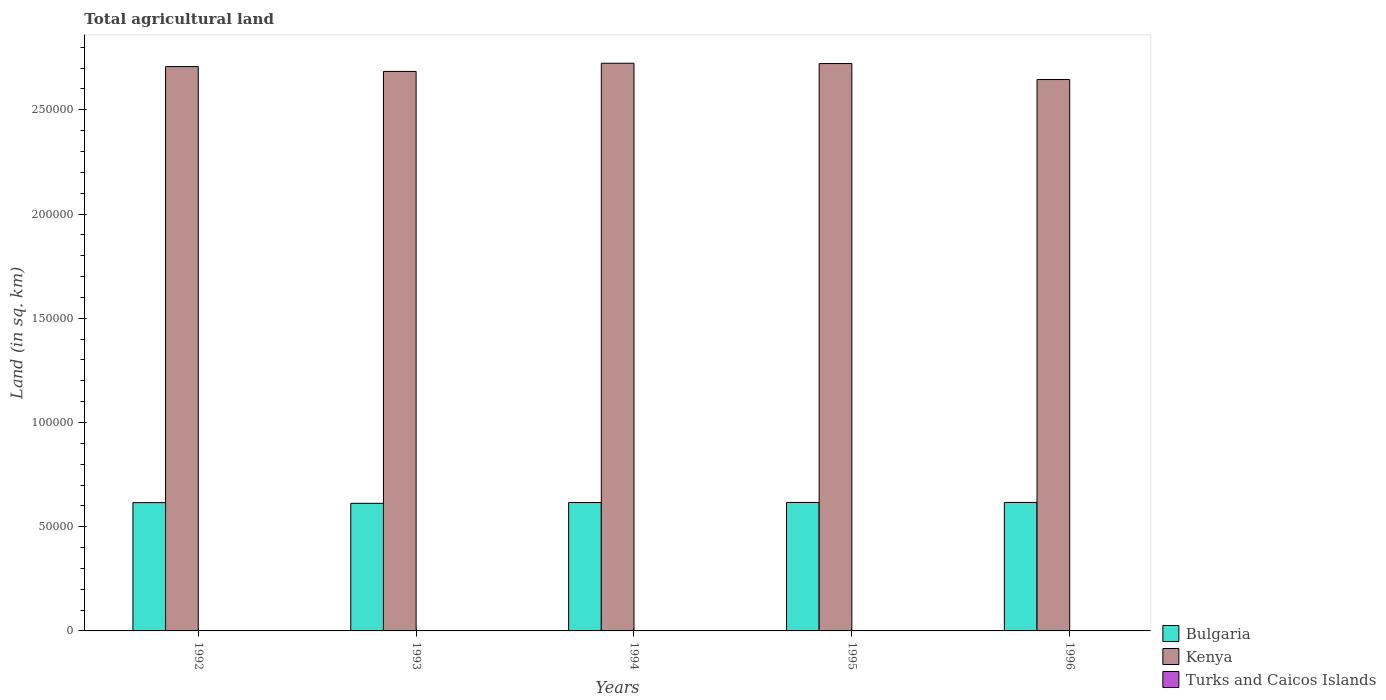How many groups of bars are there?
Provide a short and direct response. 5. Are the number of bars on each tick of the X-axis equal?
Keep it short and to the point. Yes. In how many cases, is the number of bars for a given year not equal to the number of legend labels?
Provide a succinct answer. 0. What is the total agricultural land in Turks and Caicos Islands in 1996?
Offer a very short reply. 10. Across all years, what is the maximum total agricultural land in Bulgaria?
Make the answer very short. 6.16e+04. Across all years, what is the minimum total agricultural land in Kenya?
Give a very brief answer. 2.65e+05. In which year was the total agricultural land in Bulgaria maximum?
Offer a terse response. 1995. In which year was the total agricultural land in Turks and Caicos Islands minimum?
Keep it short and to the point. 1992. What is the total total agricultural land in Kenya in the graph?
Your response must be concise. 1.35e+06. What is the difference between the total agricultural land in Bulgaria in 1992 and the total agricultural land in Turks and Caicos Islands in 1994?
Offer a terse response. 6.15e+04. What is the average total agricultural land in Kenya per year?
Give a very brief answer. 2.70e+05. In the year 1993, what is the difference between the total agricultural land in Bulgaria and total agricultural land in Turks and Caicos Islands?
Your response must be concise. 6.12e+04. In how many years, is the total agricultural land in Turks and Caicos Islands greater than 30000 sq.km?
Give a very brief answer. 0. What is the ratio of the total agricultural land in Bulgaria in 1995 to that in 1996?
Offer a terse response. 1. Is the total agricultural land in Bulgaria in 1992 less than that in 1995?
Offer a very short reply. Yes. Is the difference between the total agricultural land in Bulgaria in 1992 and 1995 greater than the difference between the total agricultural land in Turks and Caicos Islands in 1992 and 1995?
Ensure brevity in your answer.  No. What is the difference between the highest and the second highest total agricultural land in Kenya?
Make the answer very short. 140. What is the difference between the highest and the lowest total agricultural land in Kenya?
Make the answer very short. 7810. What does the 3rd bar from the left in 1992 represents?
Give a very brief answer. Turks and Caicos Islands. What does the 1st bar from the right in 1993 represents?
Give a very brief answer. Turks and Caicos Islands. How many bars are there?
Provide a succinct answer. 15. Are all the bars in the graph horizontal?
Your answer should be compact. No. Does the graph contain any zero values?
Provide a succinct answer. No. How are the legend labels stacked?
Keep it short and to the point. Vertical. What is the title of the graph?
Ensure brevity in your answer.  Total agricultural land. What is the label or title of the Y-axis?
Your answer should be compact. Land (in sq. km). What is the Land (in sq. km) of Bulgaria in 1992?
Your answer should be very brief. 6.15e+04. What is the Land (in sq. km) of Kenya in 1992?
Offer a terse response. 2.71e+05. What is the Land (in sq. km) of Turks and Caicos Islands in 1992?
Make the answer very short. 10. What is the Land (in sq. km) of Bulgaria in 1993?
Your answer should be compact. 6.12e+04. What is the Land (in sq. km) in Kenya in 1993?
Give a very brief answer. 2.68e+05. What is the Land (in sq. km) of Bulgaria in 1994?
Keep it short and to the point. 6.16e+04. What is the Land (in sq. km) of Kenya in 1994?
Your answer should be compact. 2.72e+05. What is the Land (in sq. km) in Bulgaria in 1995?
Provide a short and direct response. 6.16e+04. What is the Land (in sq. km) of Kenya in 1995?
Offer a very short reply. 2.72e+05. What is the Land (in sq. km) in Bulgaria in 1996?
Offer a very short reply. 6.16e+04. What is the Land (in sq. km) of Kenya in 1996?
Offer a very short reply. 2.65e+05. Across all years, what is the maximum Land (in sq. km) of Bulgaria?
Your answer should be very brief. 6.16e+04. Across all years, what is the maximum Land (in sq. km) in Kenya?
Ensure brevity in your answer.  2.72e+05. Across all years, what is the minimum Land (in sq. km) in Bulgaria?
Offer a terse response. 6.12e+04. Across all years, what is the minimum Land (in sq. km) of Kenya?
Make the answer very short. 2.65e+05. What is the total Land (in sq. km) in Bulgaria in the graph?
Your answer should be very brief. 3.08e+05. What is the total Land (in sq. km) of Kenya in the graph?
Offer a very short reply. 1.35e+06. What is the total Land (in sq. km) in Turks and Caicos Islands in the graph?
Ensure brevity in your answer.  50. What is the difference between the Land (in sq. km) of Bulgaria in 1992 and that in 1993?
Offer a very short reply. 330. What is the difference between the Land (in sq. km) of Kenya in 1992 and that in 1993?
Your answer should be compact. 2320. What is the difference between the Land (in sq. km) of Kenya in 1992 and that in 1994?
Your answer should be compact. -1600. What is the difference between the Land (in sq. km) of Turks and Caicos Islands in 1992 and that in 1994?
Give a very brief answer. 0. What is the difference between the Land (in sq. km) of Bulgaria in 1992 and that in 1995?
Make the answer very short. -100. What is the difference between the Land (in sq. km) of Kenya in 1992 and that in 1995?
Your response must be concise. -1460. What is the difference between the Land (in sq. km) of Turks and Caicos Islands in 1992 and that in 1995?
Your answer should be very brief. 0. What is the difference between the Land (in sq. km) in Bulgaria in 1992 and that in 1996?
Your answer should be very brief. -100. What is the difference between the Land (in sq. km) of Kenya in 1992 and that in 1996?
Offer a terse response. 6210. What is the difference between the Land (in sq. km) in Bulgaria in 1993 and that in 1994?
Keep it short and to the point. -380. What is the difference between the Land (in sq. km) of Kenya in 1993 and that in 1994?
Keep it short and to the point. -3920. What is the difference between the Land (in sq. km) of Bulgaria in 1993 and that in 1995?
Offer a very short reply. -430. What is the difference between the Land (in sq. km) of Kenya in 1993 and that in 1995?
Your answer should be compact. -3780. What is the difference between the Land (in sq. km) of Bulgaria in 1993 and that in 1996?
Provide a succinct answer. -430. What is the difference between the Land (in sq. km) of Kenya in 1993 and that in 1996?
Provide a short and direct response. 3890. What is the difference between the Land (in sq. km) in Turks and Caicos Islands in 1993 and that in 1996?
Your answer should be compact. 0. What is the difference between the Land (in sq. km) of Kenya in 1994 and that in 1995?
Give a very brief answer. 140. What is the difference between the Land (in sq. km) in Kenya in 1994 and that in 1996?
Keep it short and to the point. 7810. What is the difference between the Land (in sq. km) in Turks and Caicos Islands in 1994 and that in 1996?
Provide a succinct answer. 0. What is the difference between the Land (in sq. km) in Bulgaria in 1995 and that in 1996?
Provide a succinct answer. 0. What is the difference between the Land (in sq. km) in Kenya in 1995 and that in 1996?
Give a very brief answer. 7670. What is the difference between the Land (in sq. km) in Bulgaria in 1992 and the Land (in sq. km) in Kenya in 1993?
Provide a short and direct response. -2.07e+05. What is the difference between the Land (in sq. km) in Bulgaria in 1992 and the Land (in sq. km) in Turks and Caicos Islands in 1993?
Give a very brief answer. 6.15e+04. What is the difference between the Land (in sq. km) in Kenya in 1992 and the Land (in sq. km) in Turks and Caicos Islands in 1993?
Offer a very short reply. 2.71e+05. What is the difference between the Land (in sq. km) in Bulgaria in 1992 and the Land (in sq. km) in Kenya in 1994?
Offer a very short reply. -2.11e+05. What is the difference between the Land (in sq. km) of Bulgaria in 1992 and the Land (in sq. km) of Turks and Caicos Islands in 1994?
Your response must be concise. 6.15e+04. What is the difference between the Land (in sq. km) of Kenya in 1992 and the Land (in sq. km) of Turks and Caicos Islands in 1994?
Provide a succinct answer. 2.71e+05. What is the difference between the Land (in sq. km) in Bulgaria in 1992 and the Land (in sq. km) in Kenya in 1995?
Your response must be concise. -2.11e+05. What is the difference between the Land (in sq. km) in Bulgaria in 1992 and the Land (in sq. km) in Turks and Caicos Islands in 1995?
Your answer should be compact. 6.15e+04. What is the difference between the Land (in sq. km) in Kenya in 1992 and the Land (in sq. km) in Turks and Caicos Islands in 1995?
Your answer should be very brief. 2.71e+05. What is the difference between the Land (in sq. km) of Bulgaria in 1992 and the Land (in sq. km) of Kenya in 1996?
Your answer should be very brief. -2.03e+05. What is the difference between the Land (in sq. km) in Bulgaria in 1992 and the Land (in sq. km) in Turks and Caicos Islands in 1996?
Your response must be concise. 6.15e+04. What is the difference between the Land (in sq. km) of Kenya in 1992 and the Land (in sq. km) of Turks and Caicos Islands in 1996?
Provide a short and direct response. 2.71e+05. What is the difference between the Land (in sq. km) of Bulgaria in 1993 and the Land (in sq. km) of Kenya in 1994?
Provide a succinct answer. -2.11e+05. What is the difference between the Land (in sq. km) in Bulgaria in 1993 and the Land (in sq. km) in Turks and Caicos Islands in 1994?
Your answer should be compact. 6.12e+04. What is the difference between the Land (in sq. km) in Kenya in 1993 and the Land (in sq. km) in Turks and Caicos Islands in 1994?
Your answer should be compact. 2.68e+05. What is the difference between the Land (in sq. km) in Bulgaria in 1993 and the Land (in sq. km) in Kenya in 1995?
Your response must be concise. -2.11e+05. What is the difference between the Land (in sq. km) of Bulgaria in 1993 and the Land (in sq. km) of Turks and Caicos Islands in 1995?
Give a very brief answer. 6.12e+04. What is the difference between the Land (in sq. km) of Kenya in 1993 and the Land (in sq. km) of Turks and Caicos Islands in 1995?
Your answer should be compact. 2.68e+05. What is the difference between the Land (in sq. km) of Bulgaria in 1993 and the Land (in sq. km) of Kenya in 1996?
Offer a very short reply. -2.03e+05. What is the difference between the Land (in sq. km) in Bulgaria in 1993 and the Land (in sq. km) in Turks and Caicos Islands in 1996?
Offer a very short reply. 6.12e+04. What is the difference between the Land (in sq. km) in Kenya in 1993 and the Land (in sq. km) in Turks and Caicos Islands in 1996?
Ensure brevity in your answer.  2.68e+05. What is the difference between the Land (in sq. km) in Bulgaria in 1994 and the Land (in sq. km) in Kenya in 1995?
Your answer should be very brief. -2.11e+05. What is the difference between the Land (in sq. km) of Bulgaria in 1994 and the Land (in sq. km) of Turks and Caicos Islands in 1995?
Provide a succinct answer. 6.16e+04. What is the difference between the Land (in sq. km) of Kenya in 1994 and the Land (in sq. km) of Turks and Caicos Islands in 1995?
Make the answer very short. 2.72e+05. What is the difference between the Land (in sq. km) in Bulgaria in 1994 and the Land (in sq. km) in Kenya in 1996?
Keep it short and to the point. -2.03e+05. What is the difference between the Land (in sq. km) of Bulgaria in 1994 and the Land (in sq. km) of Turks and Caicos Islands in 1996?
Provide a short and direct response. 6.16e+04. What is the difference between the Land (in sq. km) of Kenya in 1994 and the Land (in sq. km) of Turks and Caicos Islands in 1996?
Make the answer very short. 2.72e+05. What is the difference between the Land (in sq. km) in Bulgaria in 1995 and the Land (in sq. km) in Kenya in 1996?
Offer a very short reply. -2.03e+05. What is the difference between the Land (in sq. km) of Bulgaria in 1995 and the Land (in sq. km) of Turks and Caicos Islands in 1996?
Provide a short and direct response. 6.16e+04. What is the difference between the Land (in sq. km) in Kenya in 1995 and the Land (in sq. km) in Turks and Caicos Islands in 1996?
Ensure brevity in your answer.  2.72e+05. What is the average Land (in sq. km) of Bulgaria per year?
Your answer should be compact. 6.15e+04. What is the average Land (in sq. km) of Kenya per year?
Your response must be concise. 2.70e+05. In the year 1992, what is the difference between the Land (in sq. km) of Bulgaria and Land (in sq. km) of Kenya?
Provide a short and direct response. -2.09e+05. In the year 1992, what is the difference between the Land (in sq. km) of Bulgaria and Land (in sq. km) of Turks and Caicos Islands?
Make the answer very short. 6.15e+04. In the year 1992, what is the difference between the Land (in sq. km) of Kenya and Land (in sq. km) of Turks and Caicos Islands?
Give a very brief answer. 2.71e+05. In the year 1993, what is the difference between the Land (in sq. km) in Bulgaria and Land (in sq. km) in Kenya?
Provide a short and direct response. -2.07e+05. In the year 1993, what is the difference between the Land (in sq. km) of Bulgaria and Land (in sq. km) of Turks and Caicos Islands?
Make the answer very short. 6.12e+04. In the year 1993, what is the difference between the Land (in sq. km) in Kenya and Land (in sq. km) in Turks and Caicos Islands?
Offer a very short reply. 2.68e+05. In the year 1994, what is the difference between the Land (in sq. km) of Bulgaria and Land (in sq. km) of Kenya?
Your answer should be very brief. -2.11e+05. In the year 1994, what is the difference between the Land (in sq. km) in Bulgaria and Land (in sq. km) in Turks and Caicos Islands?
Offer a terse response. 6.16e+04. In the year 1994, what is the difference between the Land (in sq. km) of Kenya and Land (in sq. km) of Turks and Caicos Islands?
Offer a terse response. 2.72e+05. In the year 1995, what is the difference between the Land (in sq. km) in Bulgaria and Land (in sq. km) in Kenya?
Make the answer very short. -2.11e+05. In the year 1995, what is the difference between the Land (in sq. km) of Bulgaria and Land (in sq. km) of Turks and Caicos Islands?
Give a very brief answer. 6.16e+04. In the year 1995, what is the difference between the Land (in sq. km) in Kenya and Land (in sq. km) in Turks and Caicos Islands?
Your answer should be very brief. 2.72e+05. In the year 1996, what is the difference between the Land (in sq. km) of Bulgaria and Land (in sq. km) of Kenya?
Offer a very short reply. -2.03e+05. In the year 1996, what is the difference between the Land (in sq. km) of Bulgaria and Land (in sq. km) of Turks and Caicos Islands?
Your answer should be compact. 6.16e+04. In the year 1996, what is the difference between the Land (in sq. km) in Kenya and Land (in sq. km) in Turks and Caicos Islands?
Offer a very short reply. 2.64e+05. What is the ratio of the Land (in sq. km) of Bulgaria in 1992 to that in 1993?
Offer a very short reply. 1.01. What is the ratio of the Land (in sq. km) in Kenya in 1992 to that in 1993?
Make the answer very short. 1.01. What is the ratio of the Land (in sq. km) in Kenya in 1992 to that in 1994?
Keep it short and to the point. 0.99. What is the ratio of the Land (in sq. km) of Turks and Caicos Islands in 1992 to that in 1994?
Your answer should be compact. 1. What is the ratio of the Land (in sq. km) in Kenya in 1992 to that in 1995?
Provide a short and direct response. 0.99. What is the ratio of the Land (in sq. km) of Kenya in 1992 to that in 1996?
Offer a terse response. 1.02. What is the ratio of the Land (in sq. km) of Kenya in 1993 to that in 1994?
Ensure brevity in your answer.  0.99. What is the ratio of the Land (in sq. km) of Kenya in 1993 to that in 1995?
Your answer should be very brief. 0.99. What is the ratio of the Land (in sq. km) in Bulgaria in 1993 to that in 1996?
Provide a succinct answer. 0.99. What is the ratio of the Land (in sq. km) of Kenya in 1993 to that in 1996?
Your response must be concise. 1.01. What is the ratio of the Land (in sq. km) of Kenya in 1994 to that in 1995?
Offer a very short reply. 1. What is the ratio of the Land (in sq. km) of Kenya in 1994 to that in 1996?
Provide a short and direct response. 1.03. What is the ratio of the Land (in sq. km) of Bulgaria in 1995 to that in 1996?
Your answer should be compact. 1. What is the ratio of the Land (in sq. km) of Kenya in 1995 to that in 1996?
Your answer should be compact. 1.03. What is the difference between the highest and the second highest Land (in sq. km) in Kenya?
Offer a very short reply. 140. What is the difference between the highest and the second highest Land (in sq. km) of Turks and Caicos Islands?
Offer a terse response. 0. What is the difference between the highest and the lowest Land (in sq. km) of Bulgaria?
Your answer should be very brief. 430. What is the difference between the highest and the lowest Land (in sq. km) in Kenya?
Ensure brevity in your answer.  7810. 